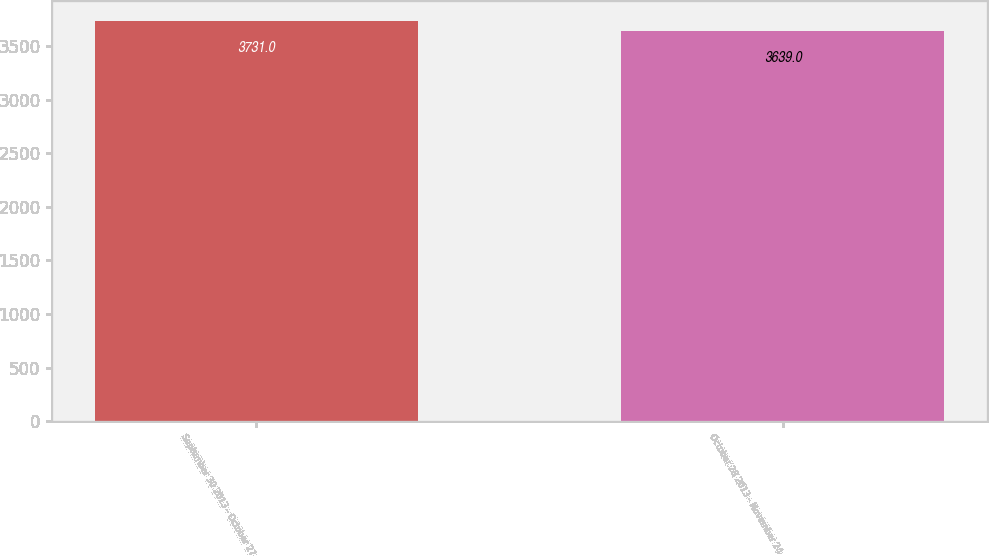<chart> <loc_0><loc_0><loc_500><loc_500><bar_chart><fcel>September 30 2013 - October 27<fcel>October 28 2013 - November 24<nl><fcel>3731<fcel>3639<nl></chart> 